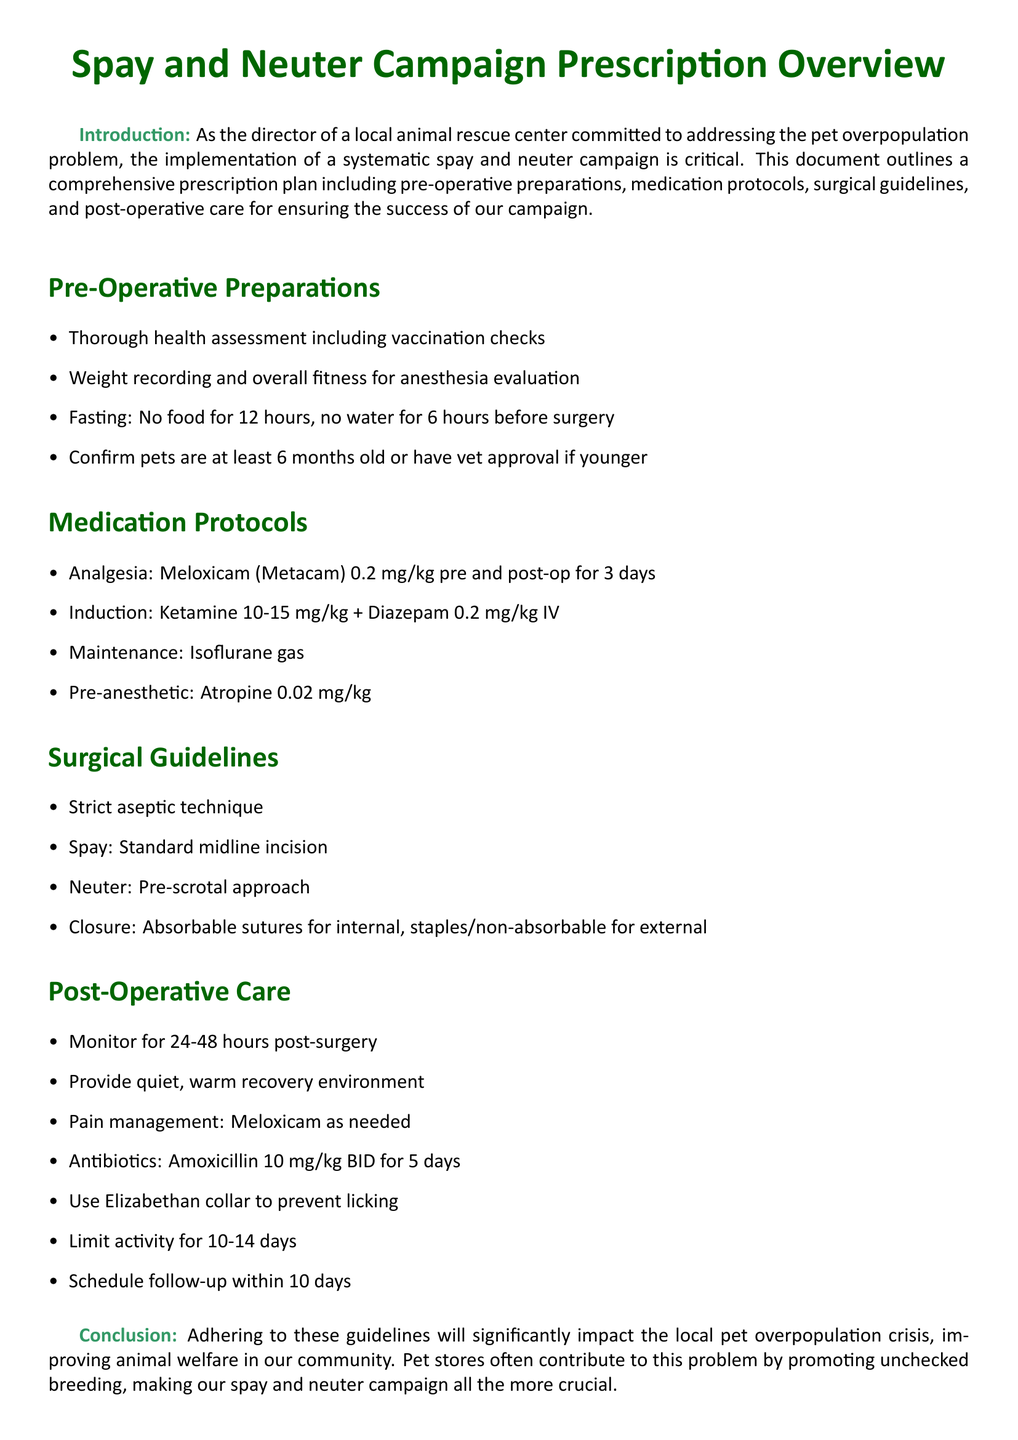What is the main purpose of the document? The purpose of the document is outlined in the introduction, emphasizing the importance of spay and neuter campaigns in addressing pet overpopulation.
Answer: Addressing the pet overpopulation problem How long should pets fast before surgery? The document specifies the fasting duration for pets before surgery.
Answer: 12 hours What medication is administered for analgesia? The document lists Meloxicam as the analgesia used for pets before and after surgery.
Answer: Meloxicam What type of incision is used for a spay? The surgical guidelines section provides specific information about the type of incision for spaying pets.
Answer: Standard midline incision How long should post-operative monitoring occur? The document specifies the duration for monitoring pets after surgery.
Answer: 24-48 hours What is used to prevent licking after surgery? The post-operative care section mentions an item to prevent animals from licking their wounds.
Answer: Elizabethan collar Which antibiotic is prescribed post-surgery? The medication protocols section identifies the antibiotic prescribed for pets post-operation.
Answer: Amoxicillin What is the weight for administering Meloxicam? The document specifies the dosage of Meloxicam in relation to the pet's weight.
Answer: 0.2 mg/kg How many days should activity be limited post-surgery? The document gives a specific duration for limiting activity post-operation.
Answer: 10-14 days What age must pets be for surgery without vet approval? The pre-operative preparations indicate the minimum age at which pets can undergo surgery without needing vet approval.
Answer: 6 months 